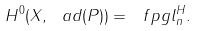<formula> <loc_0><loc_0><loc_500><loc_500>H ^ { 0 } ( X , \ a d ( P ) ) = \ f p g l _ { n } ^ { H } .</formula> 